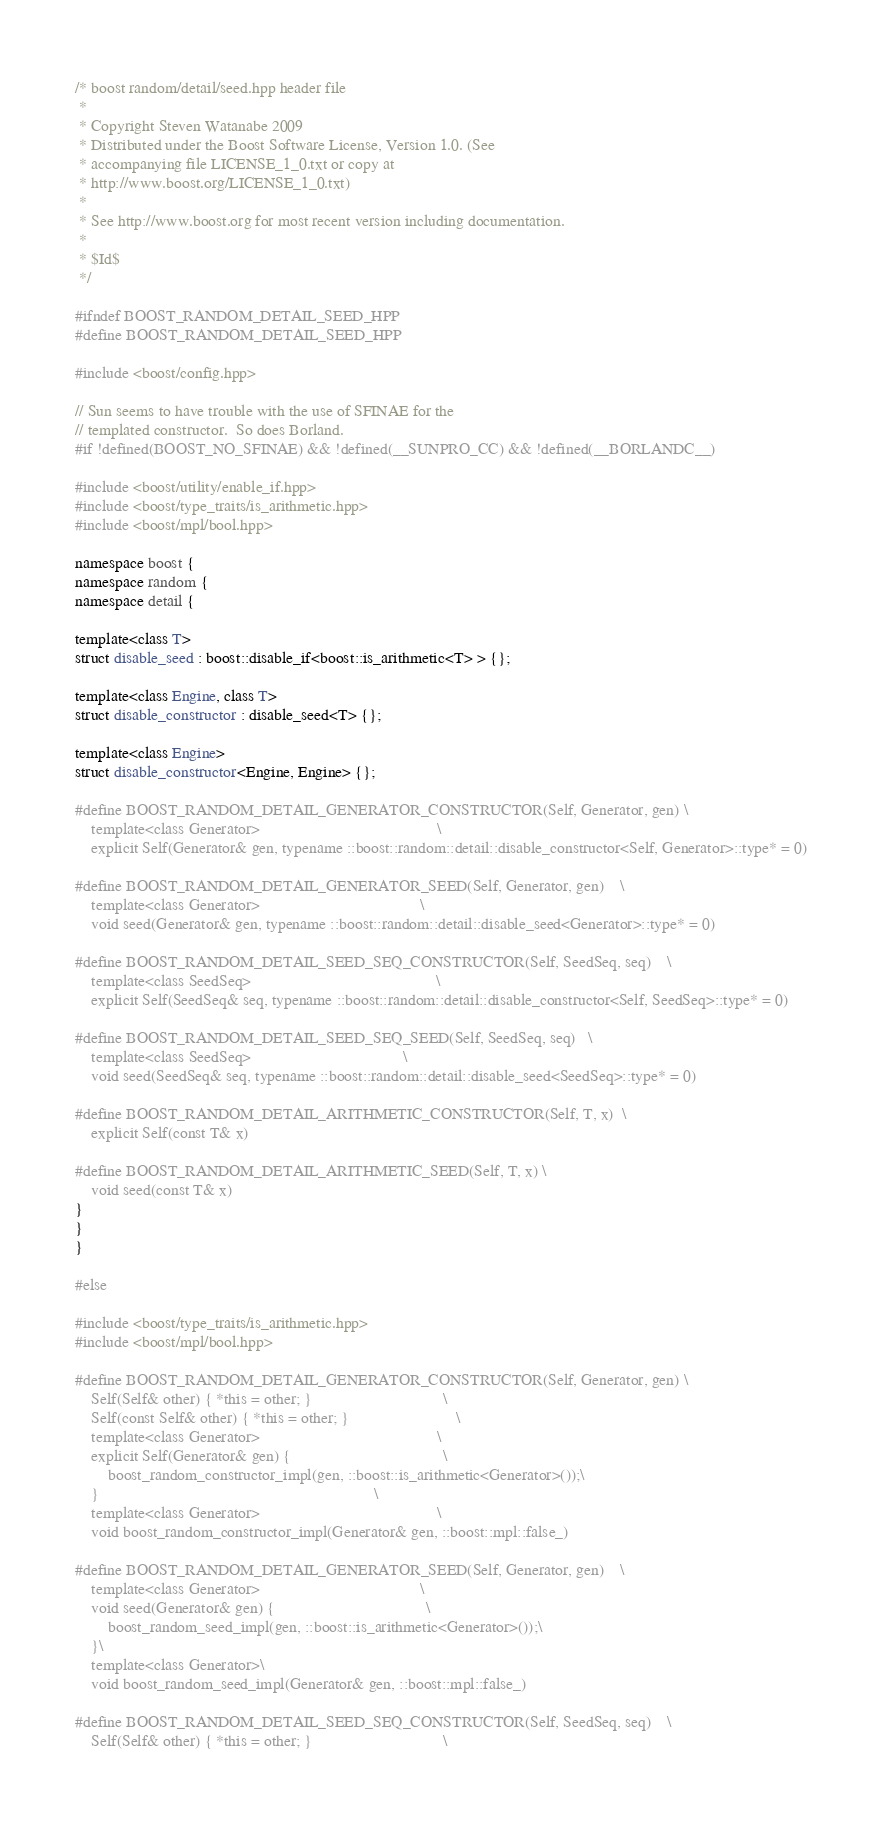<code> <loc_0><loc_0><loc_500><loc_500><_C++_>/* boost random/detail/seed.hpp header file
 *
 * Copyright Steven Watanabe 2009
 * Distributed under the Boost Software License, Version 1.0. (See
 * accompanying file LICENSE_1_0.txt or copy at
 * http://www.boost.org/LICENSE_1_0.txt)
 *
 * See http://www.boost.org for most recent version including documentation.
 *
 * $Id$
 */

#ifndef BOOST_RANDOM_DETAIL_SEED_HPP
#define BOOST_RANDOM_DETAIL_SEED_HPP

#include <boost/config.hpp>

// Sun seems to have trouble with the use of SFINAE for the
// templated constructor.  So does Borland.
#if !defined(BOOST_NO_SFINAE) && !defined(__SUNPRO_CC) && !defined(__BORLANDC__)

#include <boost/utility/enable_if.hpp>
#include <boost/type_traits/is_arithmetic.hpp>
#include <boost/mpl/bool.hpp>

namespace boost {
namespace random {
namespace detail {

template<class T>
struct disable_seed : boost::disable_if<boost::is_arithmetic<T> > {};

template<class Engine, class T>
struct disable_constructor : disable_seed<T> {};

template<class Engine>
struct disable_constructor<Engine, Engine> {};

#define BOOST_RANDOM_DETAIL_GENERATOR_CONSTRUCTOR(Self, Generator, gen) \
    template<class Generator>                                           \
    explicit Self(Generator& gen, typename ::boost::random::detail::disable_constructor<Self, Generator>::type* = 0)

#define BOOST_RANDOM_DETAIL_GENERATOR_SEED(Self, Generator, gen)    \
    template<class Generator>                                       \
    void seed(Generator& gen, typename ::boost::random::detail::disable_seed<Generator>::type* = 0)

#define BOOST_RANDOM_DETAIL_SEED_SEQ_CONSTRUCTOR(Self, SeedSeq, seq)    \
    template<class SeedSeq>                                             \
    explicit Self(SeedSeq& seq, typename ::boost::random::detail::disable_constructor<Self, SeedSeq>::type* = 0)

#define BOOST_RANDOM_DETAIL_SEED_SEQ_SEED(Self, SeedSeq, seq)   \
    template<class SeedSeq>                                     \
    void seed(SeedSeq& seq, typename ::boost::random::detail::disable_seed<SeedSeq>::type* = 0)

#define BOOST_RANDOM_DETAIL_ARITHMETIC_CONSTRUCTOR(Self, T, x)  \
    explicit Self(const T& x)

#define BOOST_RANDOM_DETAIL_ARITHMETIC_SEED(Self, T, x) \
    void seed(const T& x)
}
}
}

#else

#include <boost/type_traits/is_arithmetic.hpp>
#include <boost/mpl/bool.hpp>

#define BOOST_RANDOM_DETAIL_GENERATOR_CONSTRUCTOR(Self, Generator, gen) \
    Self(Self& other) { *this = other; }                                \
    Self(const Self& other) { *this = other; }                          \
    template<class Generator>                                           \
    explicit Self(Generator& gen) {                                     \
        boost_random_constructor_impl(gen, ::boost::is_arithmetic<Generator>());\
    }                                                                   \
    template<class Generator>                                           \
    void boost_random_constructor_impl(Generator& gen, ::boost::mpl::false_)

#define BOOST_RANDOM_DETAIL_GENERATOR_SEED(Self, Generator, gen)    \
    template<class Generator>                                       \
    void seed(Generator& gen) {                                     \
        boost_random_seed_impl(gen, ::boost::is_arithmetic<Generator>());\
    }\
    template<class Generator>\
    void boost_random_seed_impl(Generator& gen, ::boost::mpl::false_)

#define BOOST_RANDOM_DETAIL_SEED_SEQ_CONSTRUCTOR(Self, SeedSeq, seq)    \
    Self(Self& other) { *this = other; }                                \</code> 